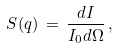<formula> <loc_0><loc_0><loc_500><loc_500>S ( { q } ) \, = \, \frac { d I } { I _ { 0 } d \Omega } \, ,</formula> 